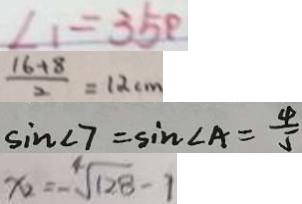<formula> <loc_0><loc_0><loc_500><loc_500>\angle 1 = 3 5 ^ { \circ } 
 \frac { 1 6 + 8 } { 2 } = 1 2 c m 
 \sin \angle 7 = \sin \angle A = \frac { 4 } { 5 } 
 x = - \sqrt [ 4 ] { 1 2 8 } - 1</formula> 